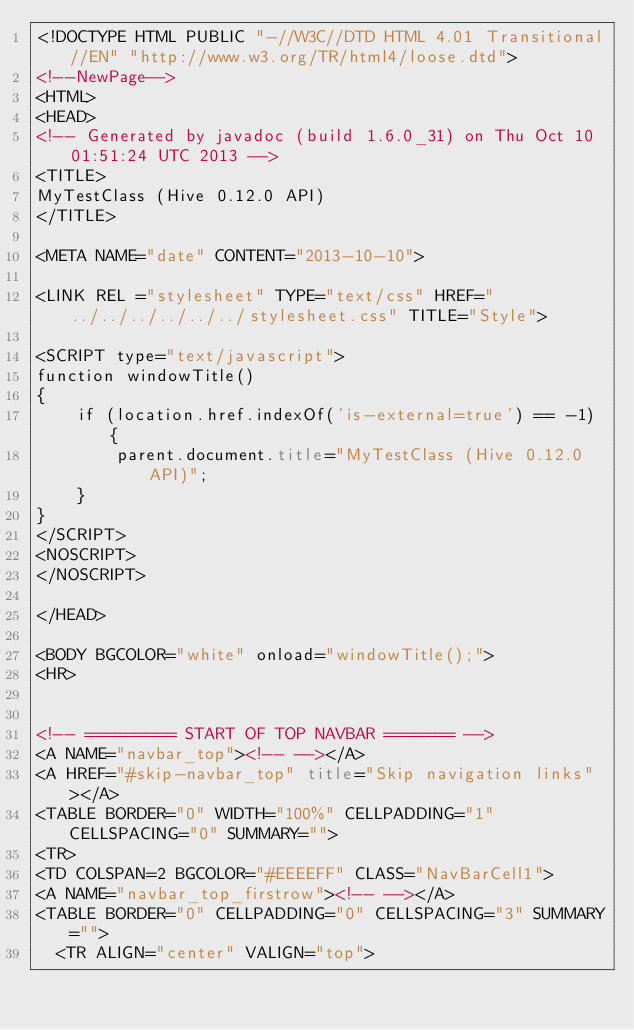<code> <loc_0><loc_0><loc_500><loc_500><_HTML_><!DOCTYPE HTML PUBLIC "-//W3C//DTD HTML 4.01 Transitional//EN" "http://www.w3.org/TR/html4/loose.dtd">
<!--NewPage-->
<HTML>
<HEAD>
<!-- Generated by javadoc (build 1.6.0_31) on Thu Oct 10 01:51:24 UTC 2013 -->
<TITLE>
MyTestClass (Hive 0.12.0 API)
</TITLE>

<META NAME="date" CONTENT="2013-10-10">

<LINK REL ="stylesheet" TYPE="text/css" HREF="../../../../../../stylesheet.css" TITLE="Style">

<SCRIPT type="text/javascript">
function windowTitle()
{
    if (location.href.indexOf('is-external=true') == -1) {
        parent.document.title="MyTestClass (Hive 0.12.0 API)";
    }
}
</SCRIPT>
<NOSCRIPT>
</NOSCRIPT>

</HEAD>

<BODY BGCOLOR="white" onload="windowTitle();">
<HR>


<!-- ========= START OF TOP NAVBAR ======= -->
<A NAME="navbar_top"><!-- --></A>
<A HREF="#skip-navbar_top" title="Skip navigation links"></A>
<TABLE BORDER="0" WIDTH="100%" CELLPADDING="1" CELLSPACING="0" SUMMARY="">
<TR>
<TD COLSPAN=2 BGCOLOR="#EEEEFF" CLASS="NavBarCell1">
<A NAME="navbar_top_firstrow"><!-- --></A>
<TABLE BORDER="0" CELLPADDING="0" CELLSPACING="3" SUMMARY="">
  <TR ALIGN="center" VALIGN="top"></code> 